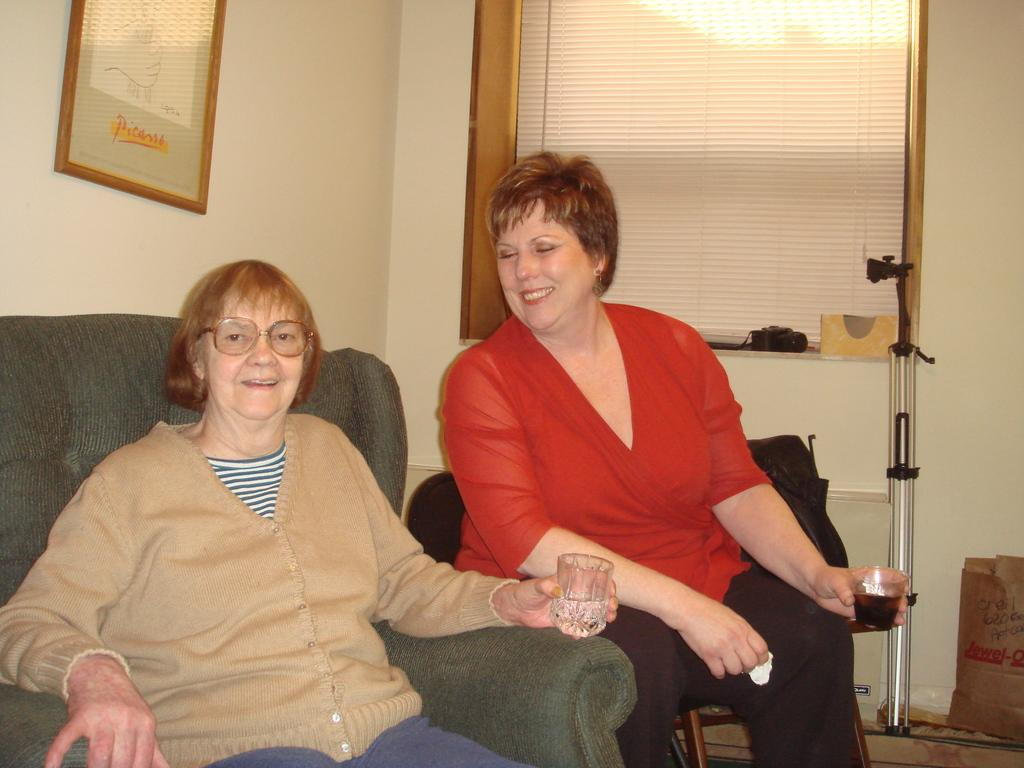How many people are in the image? There are two women in the image. What are the women holding in their hands? The women are holding glasses. What can be seen in the background of the image? There is a wall and a photo frame in the background of the image. What type of copper cap can be seen on the photo frame in the image? There is no copper cap present on the photo frame in the image. 